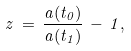Convert formula to latex. <formula><loc_0><loc_0><loc_500><loc_500>z \, = \, \frac { a ( t _ { 0 } ) } { a ( t _ { 1 } ) } \, - \, 1 ,</formula> 